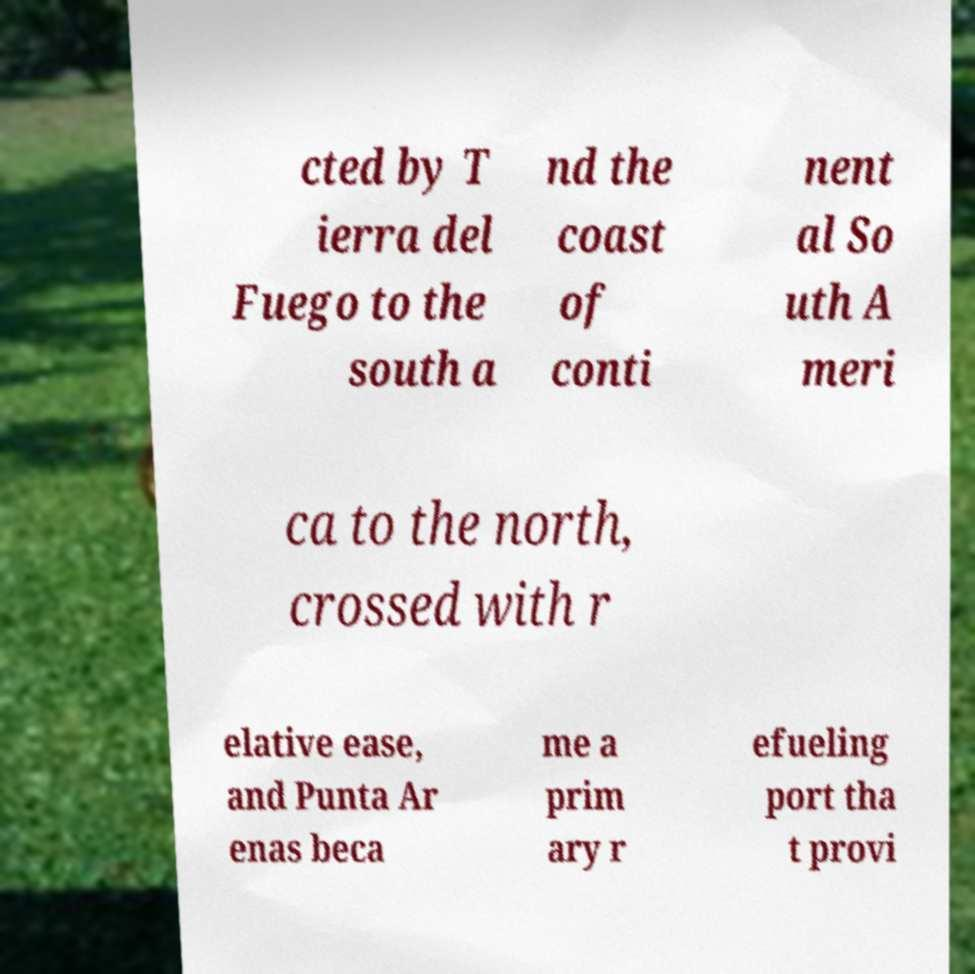Could you assist in decoding the text presented in this image and type it out clearly? cted by T ierra del Fuego to the south a nd the coast of conti nent al So uth A meri ca to the north, crossed with r elative ease, and Punta Ar enas beca me a prim ary r efueling port tha t provi 